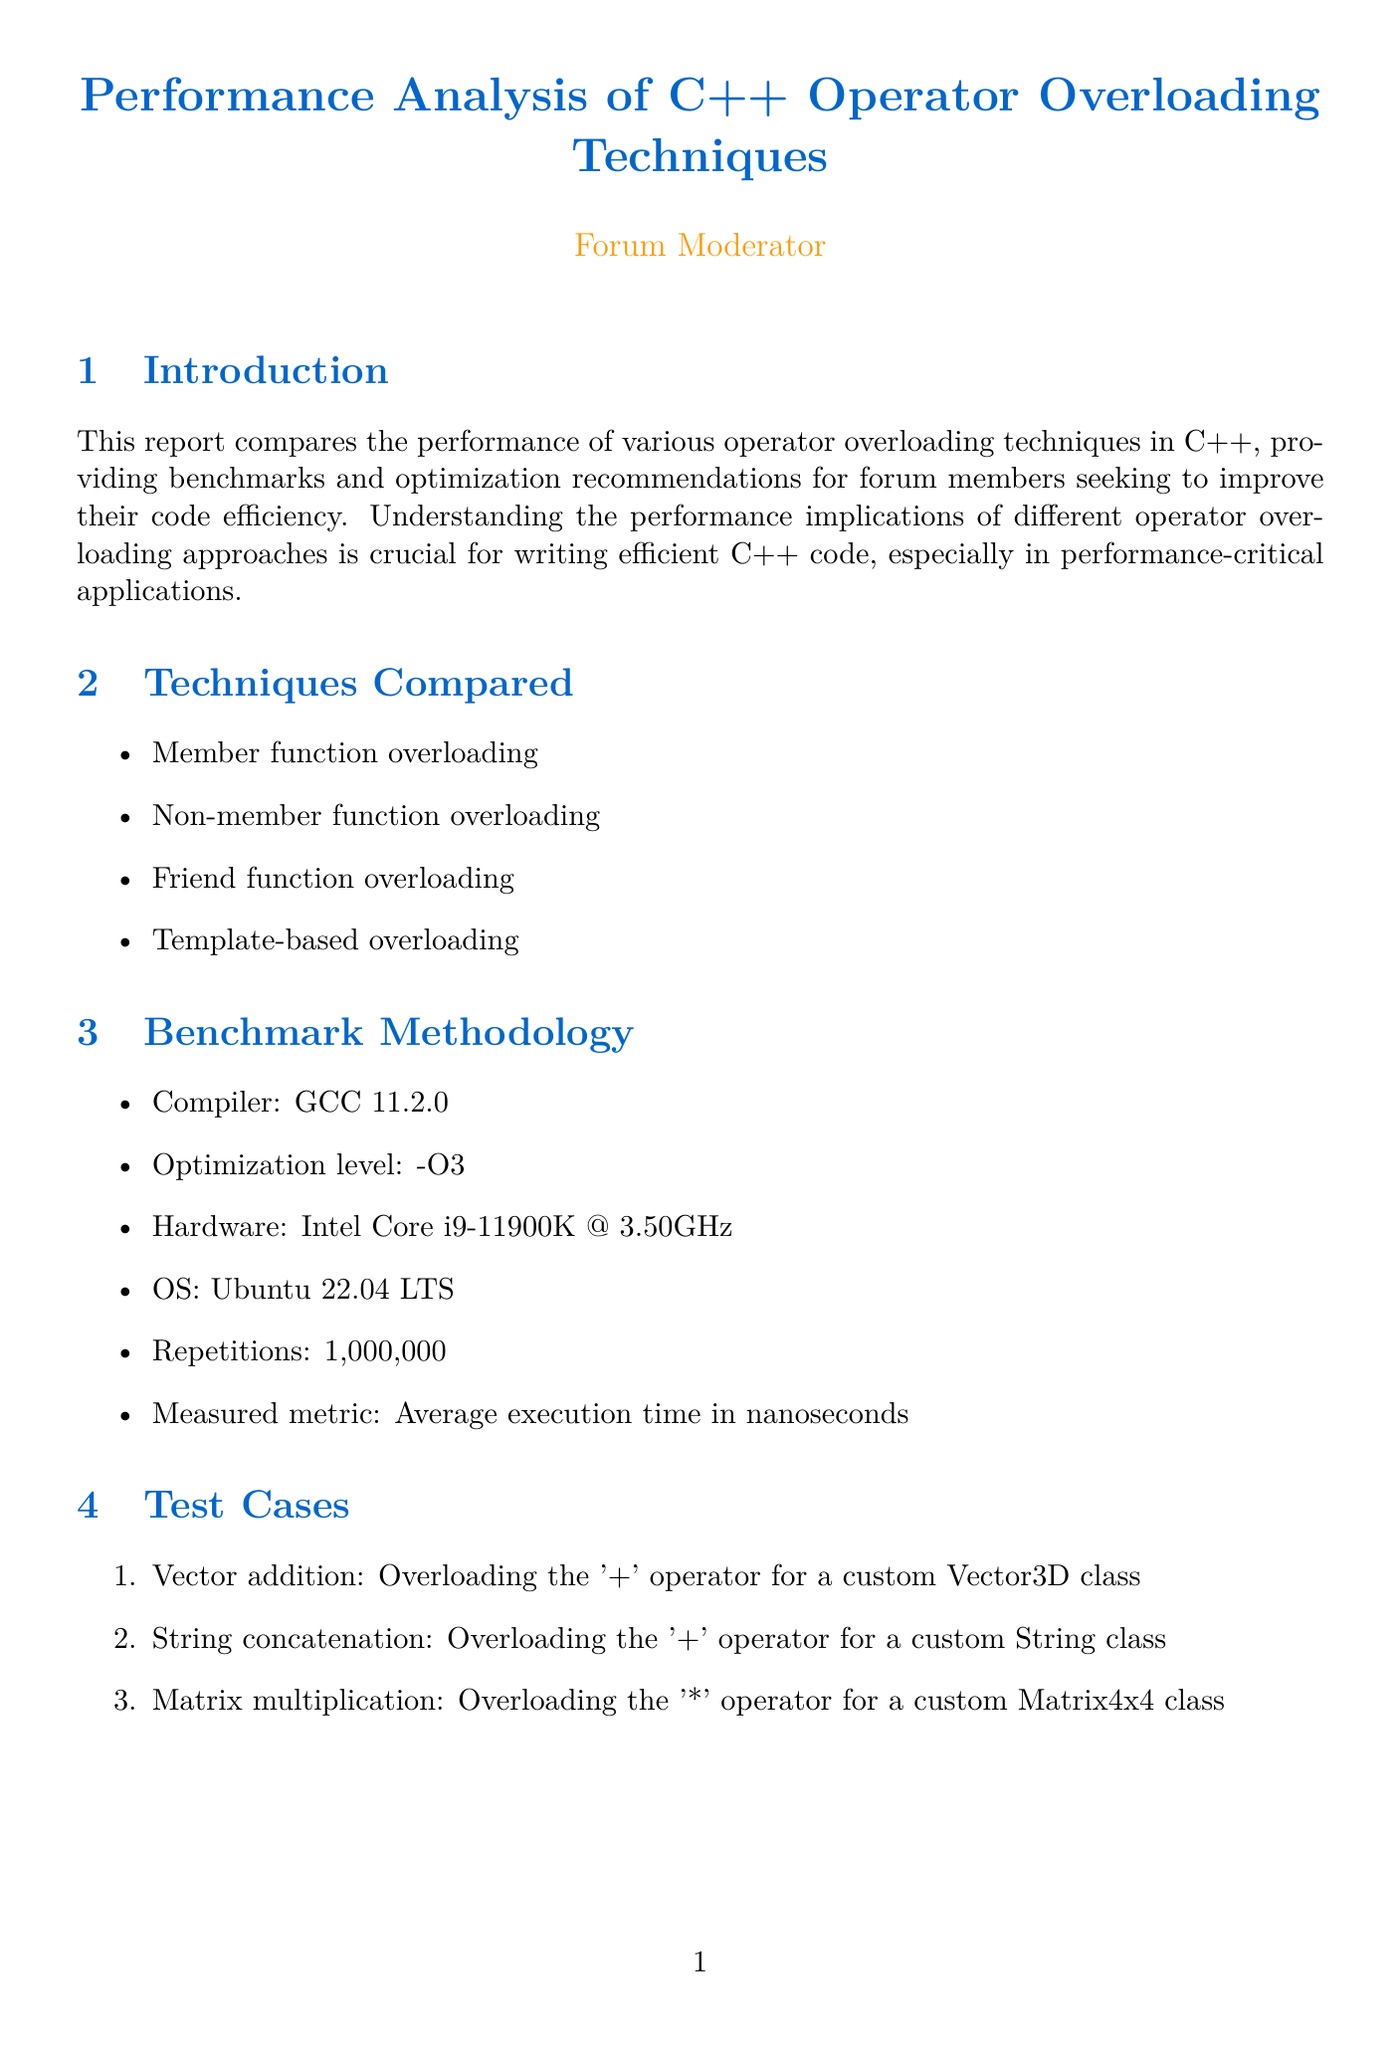What is the report title? The report title is provided at the beginning of the document, summarizing the main topic covered in the report.
Answer: Performance Analysis of C++ Operator Overloading Techniques Which compiler was used for benchmarking? The compiler information is part of the benchmark methodology section that outlines the tools and environment used for testing.
Answer: GCC 11.2.0 What was the optimization level set during testing? The optimization level is mentioned within the benchmark methodology, specifying the compiler settings utilized during the tests.
Answer: -O3 What are the three test cases mentioned? The test cases are listed in a numbered format in the document under the test cases section, describing the specific operations tested.
Answer: Vector addition, String concatenation, Matrix multiplication Which overloading technique showed the best performance in vector addition? The performance results for vector addition are detailed in the benchmark results section, indicating the fastest technique across all options tested.
Answer: Template-based What is the maximum variance observed in the vector addition test case? The variance information is discussed in the analysis section, indicating the differences in execution time between techniques for that specific test case.
Answer: 3% What does the report recommend for simple, generic operations? Recommendations for optimization are listed in an itemized format within the document, providing guidance on the preferred techniques for various scenarios.
Answer: Prefer template-based overloading Which section discusses code examples? The section dedicated to providing actual code snippets demonstrating different overloading techniques is organized in a structured way within the document.
Answer: Code Examples What is the primary conclusion of the report? The conclusion summarizes the overall findings of the report, reflecting on the results of the analysis and providing final recommendations.
Answer: Template-based overloading showed a slight performance edge 